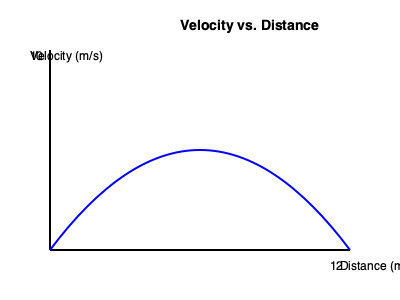Based on the velocity-distance graph for a triple jump, what is the minimum initial velocity needed to clear a distance of 12 meters, assuming the jumper maintains the velocity curve shown? To solve this problem, we need to analyze the velocity-distance graph:

1. The graph shows velocity (y-axis) vs. distance (x-axis) for a triple jump.
2. The curve represents how velocity changes with distance during the jump.
3. To clear 12 meters, we need to find the maximum velocity on the curve.
4. The peak of the curve represents the maximum velocity reached during the jump.
5. From the graph, we can estimate that the peak velocity is about 10 m/s.
6. This peak velocity occurs at approximately the midpoint of the jump (around 6 meters).
7. To clear 12 meters, the jumper must achieve at least this peak velocity.
8. The initial velocity must be equal to or greater than the peak velocity to ensure clearing the full distance.

Therefore, the minimum initial velocity needed is the same as the peak velocity shown on the graph, which is approximately 10 m/s.
Answer: $10 \text{ m/s}$ 